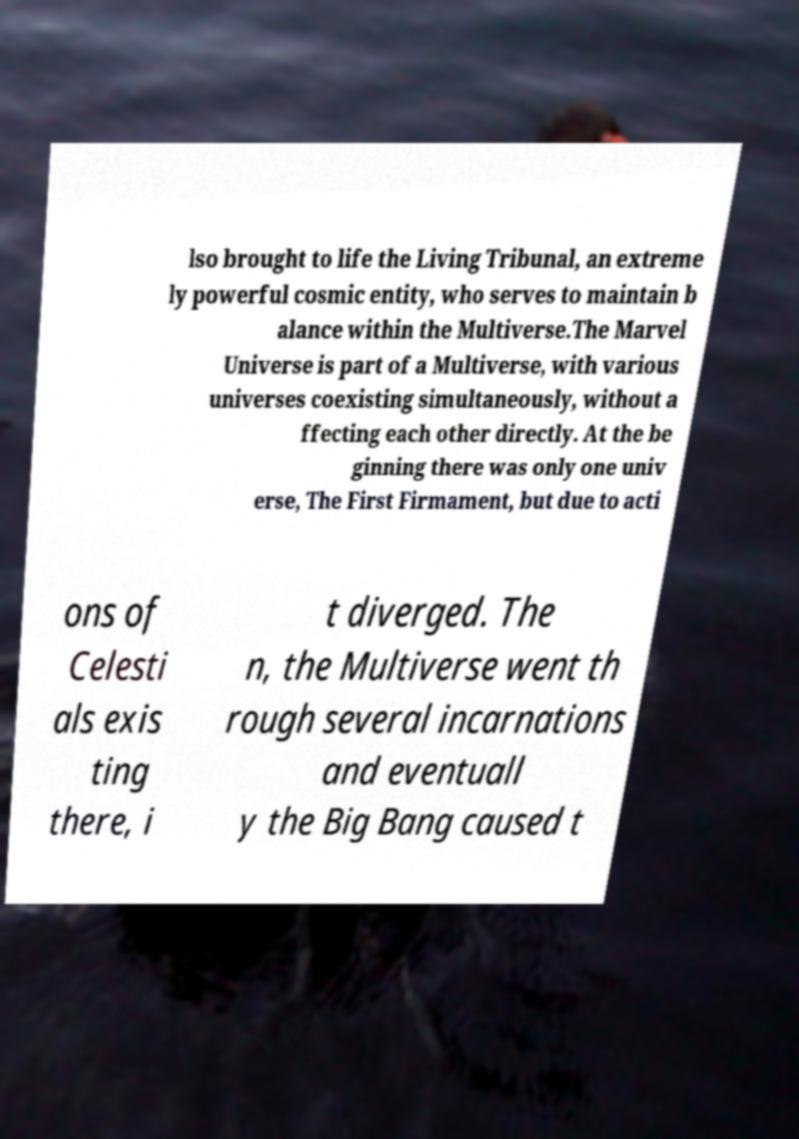For documentation purposes, I need the text within this image transcribed. Could you provide that? lso brought to life the Living Tribunal, an extreme ly powerful cosmic entity, who serves to maintain b alance within the Multiverse.The Marvel Universe is part of a Multiverse, with various universes coexisting simultaneously, without a ffecting each other directly. At the be ginning there was only one univ erse, The First Firmament, but due to acti ons of Celesti als exis ting there, i t diverged. The n, the Multiverse went th rough several incarnations and eventuall y the Big Bang caused t 